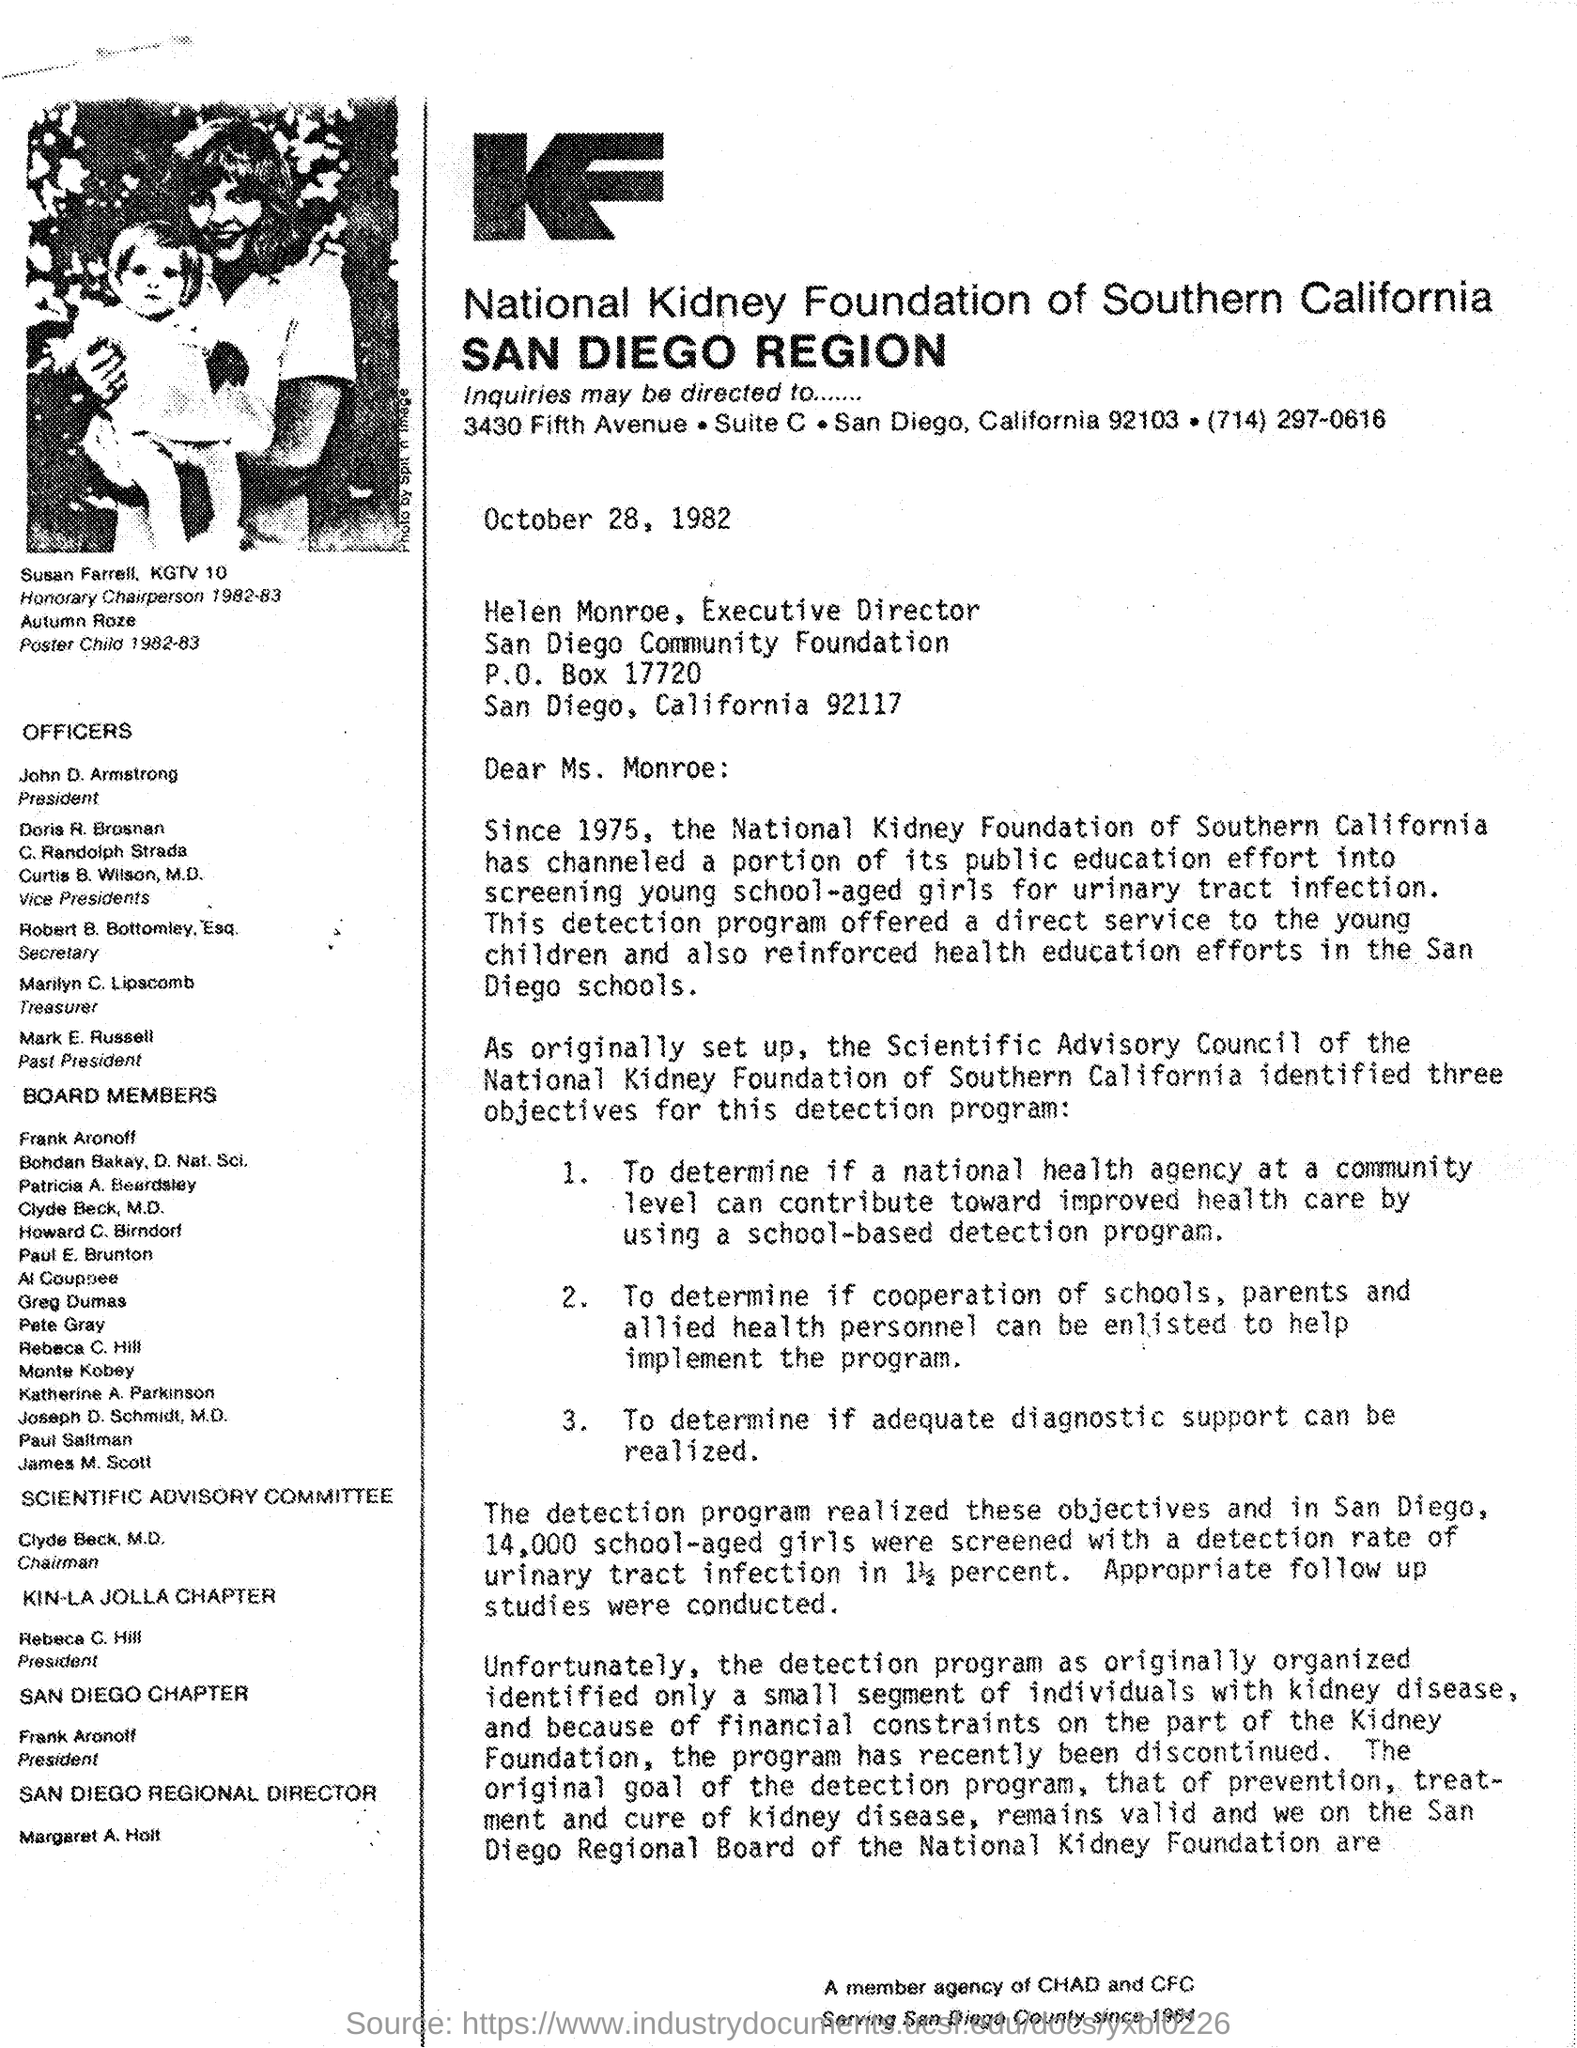Indicate a few pertinent items in this graphic. The National Kidney Foundation of Southern California has appointed Mark E. Russell as the "Past President. The letter is addressed to Helen Monroe, the Executive Director. The person whose image is featured in the document is Susan Farrell, a news anchor for KGTV 10. The President of the National Kidney Foundation of Southern California is John D. Armstrong. The Chairman of the Scientific Advisory Committee is Clyde Beck, M.D. 